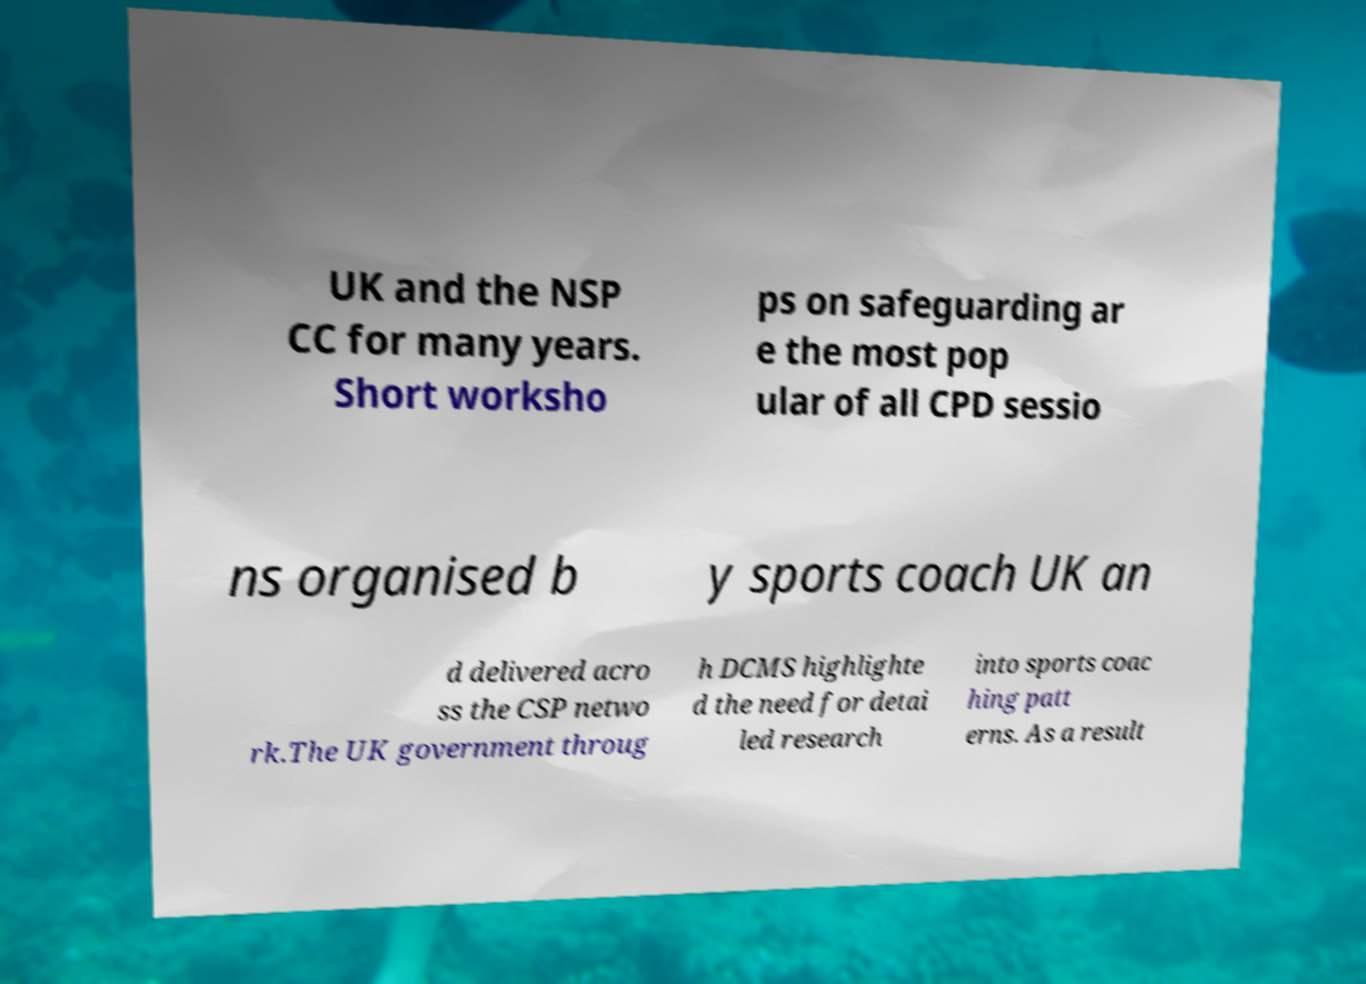Can you accurately transcribe the text from the provided image for me? UK and the NSP CC for many years. Short worksho ps on safeguarding ar e the most pop ular of all CPD sessio ns organised b y sports coach UK an d delivered acro ss the CSP netwo rk.The UK government throug h DCMS highlighte d the need for detai led research into sports coac hing patt erns. As a result 